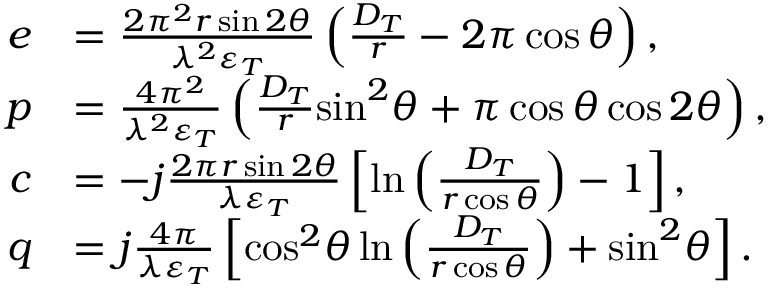<formula> <loc_0><loc_0><loc_500><loc_500>\begin{array} { r l } { e } & { = \frac { { 2 { \pi ^ { 2 } } r \sin 2 \theta } } { { { \lambda ^ { 2 } } { \varepsilon _ { T } } } } \left ( { \frac { { { D _ { T } } } } { r } - 2 \pi \cos \theta } \right ) , } \\ { p } & { = \frac { { 4 { \pi ^ { 2 } } } } { { { \lambda ^ { 2 } } { \varepsilon _ { T } } } } \left ( { \frac { { { D _ { T } } } } { r } { { \sin } ^ { 2 } } \theta + \pi \cos \theta \cos 2 \theta } \right ) , } \\ { c } & { = - j \frac { 2 \pi r \sin 2 \theta } { { \lambda { \varepsilon _ { T } } } } \left [ { \ln \left ( { \frac { { { D _ { T } } } } { r \cos \theta } } \right ) - 1 } \right ] , } \\ { q } & { = j \frac { 4 \pi } { { \lambda { \varepsilon _ { T } } } } \left [ { { { \cos } ^ { 2 } } \theta \ln \left ( { \frac { { { D _ { T } } } } { r \cos \theta } } \right ) + { { \sin } ^ { 2 } } \theta } \right ] . } \end{array}</formula> 